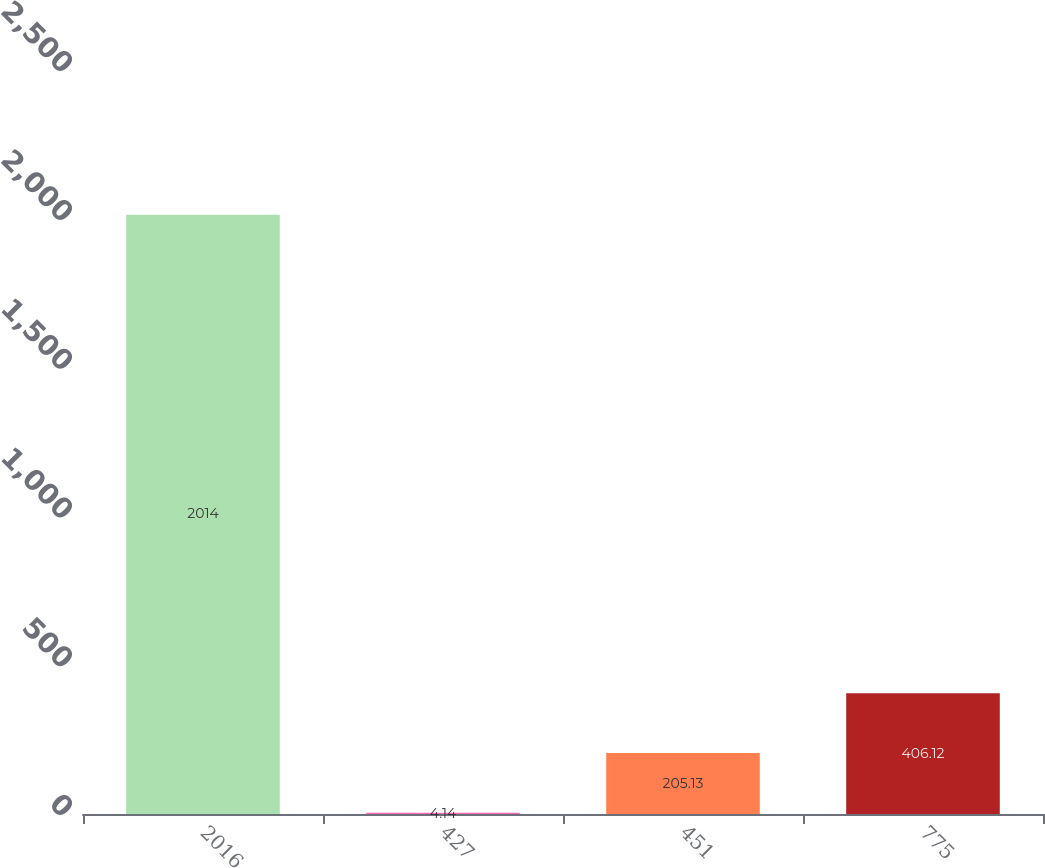Convert chart to OTSL. <chart><loc_0><loc_0><loc_500><loc_500><bar_chart><fcel>2016<fcel>427<fcel>451<fcel>775<nl><fcel>2014<fcel>4.14<fcel>205.13<fcel>406.12<nl></chart> 